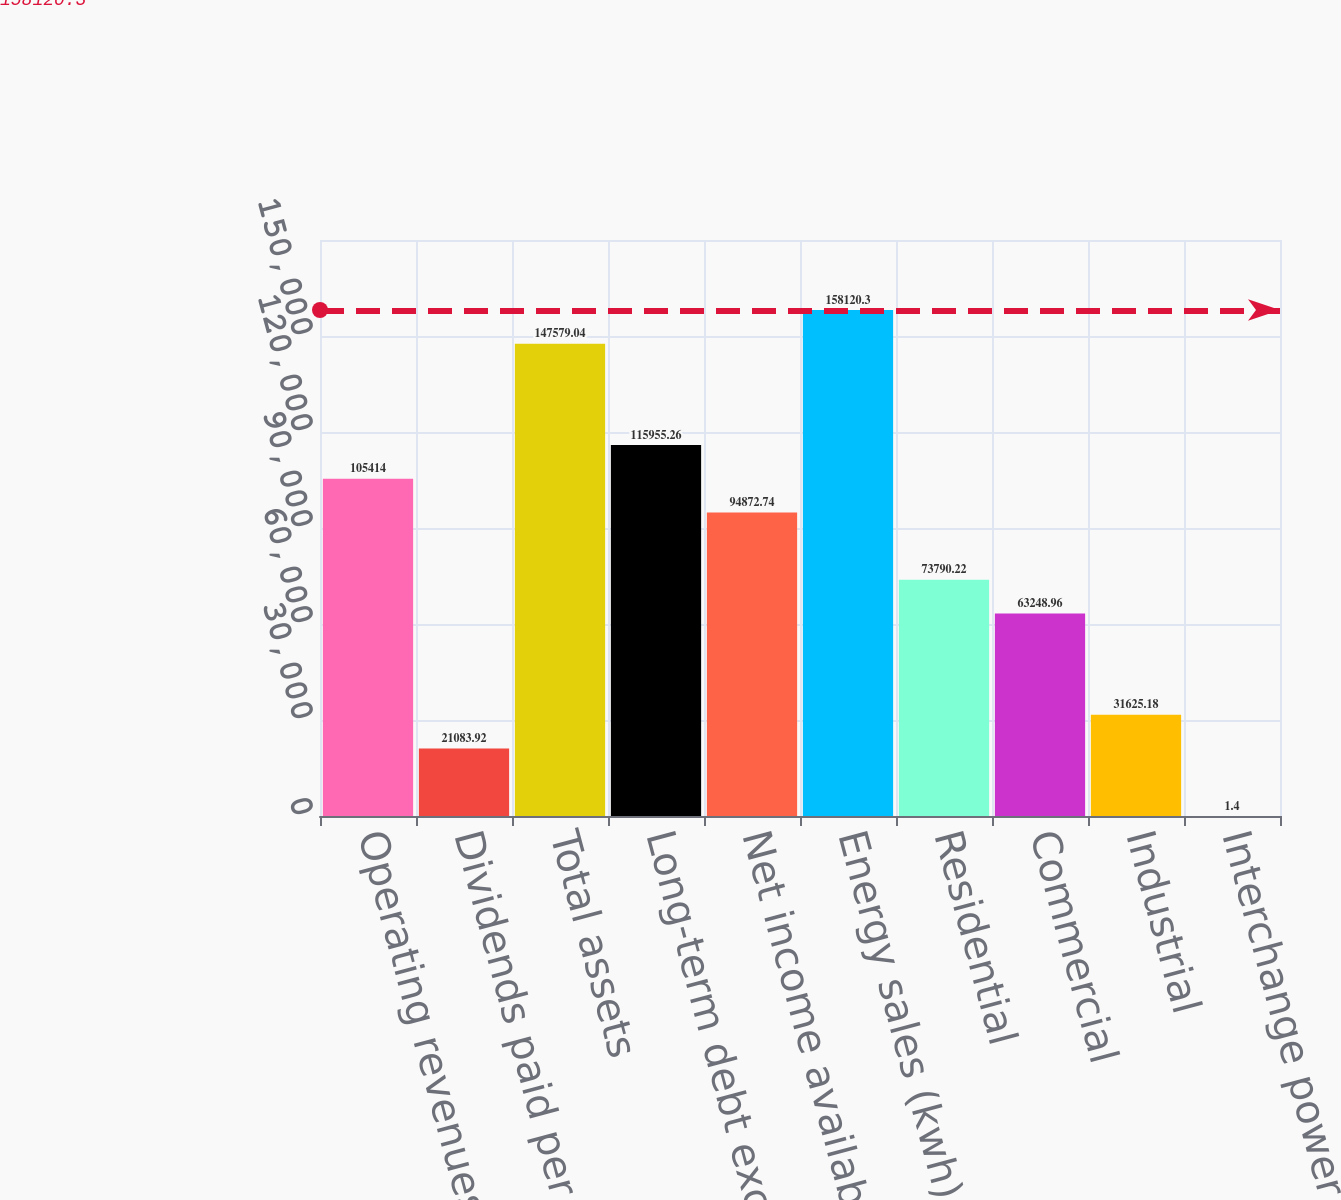Convert chart. <chart><loc_0><loc_0><loc_500><loc_500><bar_chart><fcel>Operating revenues<fcel>Dividends paid per share of<fcel>Total assets<fcel>Long-term debt excluding<fcel>Net income available to FPL<fcel>Energy sales (kwh)<fcel>Residential<fcel>Commercial<fcel>Industrial<fcel>Interchange power sales<nl><fcel>105414<fcel>21083.9<fcel>147579<fcel>115955<fcel>94872.7<fcel>158120<fcel>73790.2<fcel>63249<fcel>31625.2<fcel>1.4<nl></chart> 